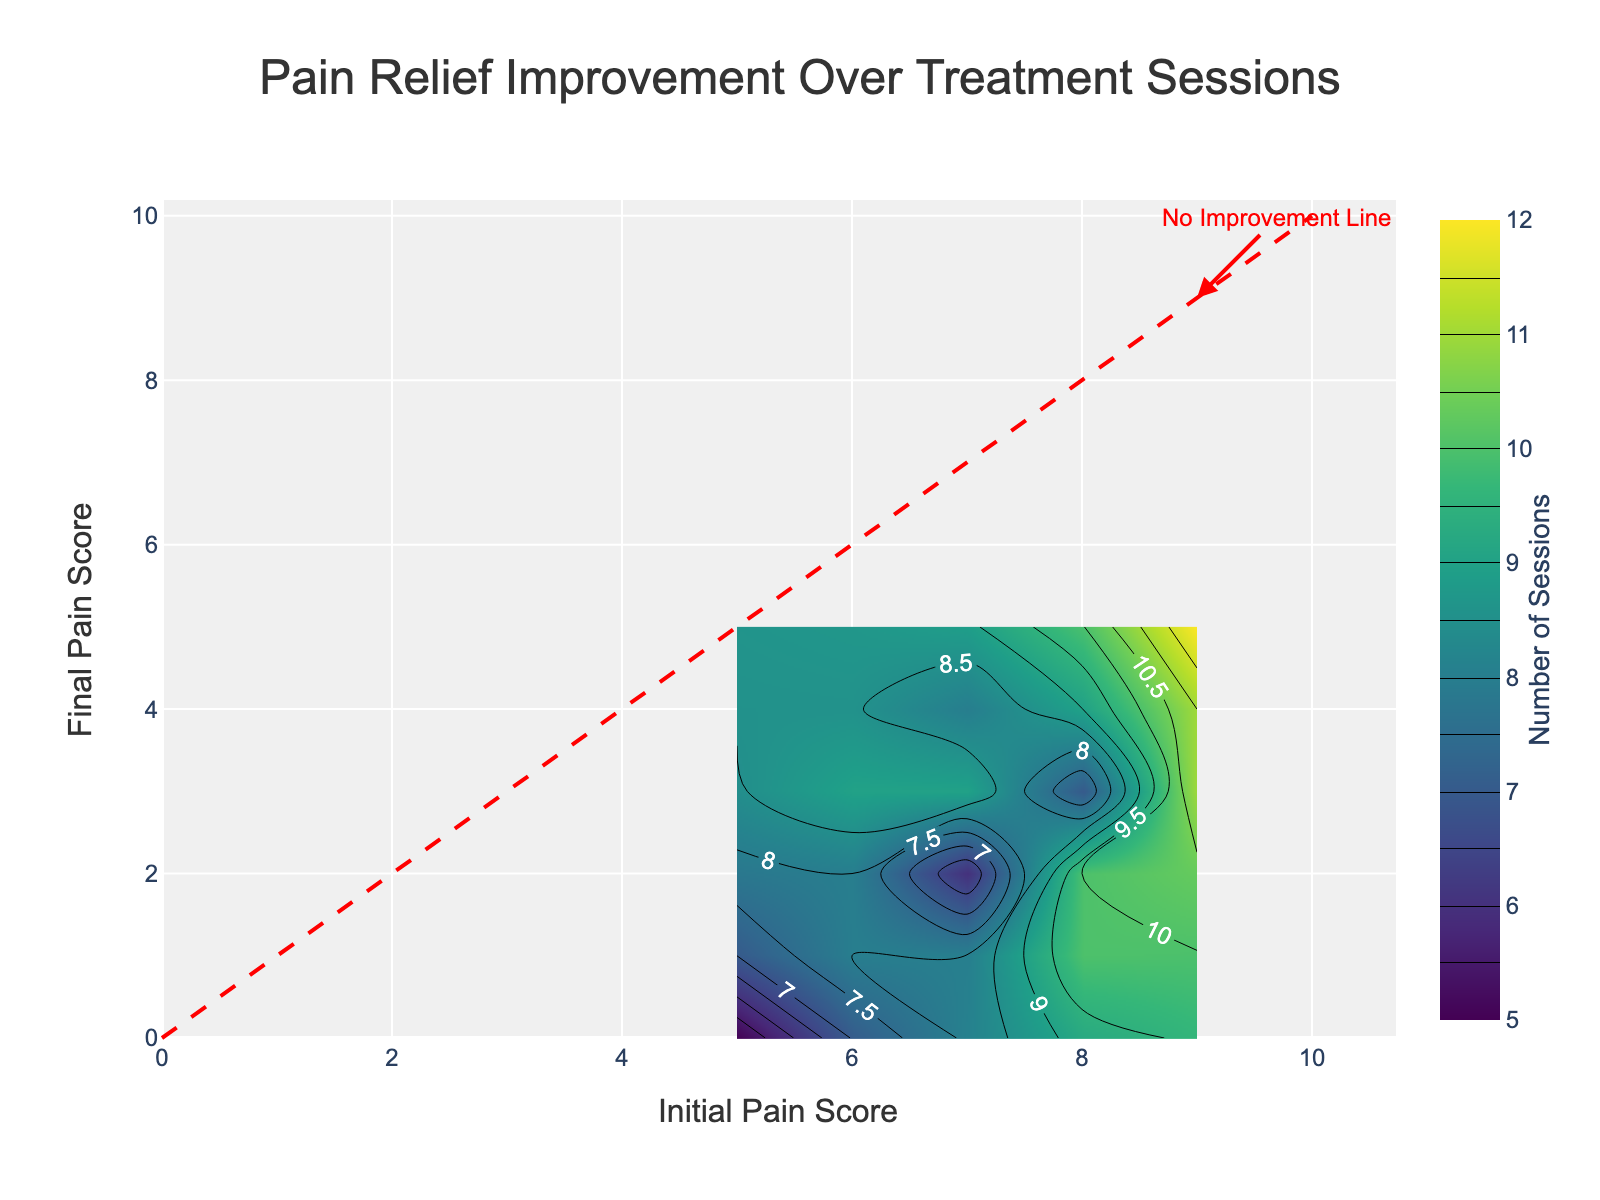What is the title of the figure? The title is placed at the top center of the figure in a larger font and reads "Pain Relief Improvement Over Treatment Sessions."
Answer: Pain Relief Improvement Over Treatment Sessions What does the color bar indicate? The color bar is labeled on the right side of the figure, and its title "Number of Sessions" shows that it represents the number of sessions patients attended.
Answer: Number of Sessions At which initial pain score do we see the maximum number of treatment sessions? Looking at the color bar, the darkest section on the plot (indicating the highest number of sessions) occurs around an initial pain score of 8.
Answer: 8 How does the final pain score change with respect to the initial pain score? Observing the contour lines, the final pain score generally decreases as the initial pain score increases, indicating improvement in pain levels after the treatment.
Answer: Decreases What is the significance of the red dashed line? The red line has an annotation and follows an increasing trend where x equals y, indicating the "No Improvement Line" where the initial pain score equals the final pain score.
Answer: No Improvement Line How many sessions are generally required for a patient with an initial pain score of 9 to achieve a final pain score of 3? By identifying the contour lines and their intersections, where the initial pain score is 9 and the final pain score is 3, it is observed around the color representing approximately 11 sessions.
Answer: 11 Compare the number of sessions required for an initial pain score of 7 to achieve final pain scores of 2, 3, and 4. Observing the contour plot, for a final pain score of 2, it is around 6 sessions; for 3, it is 8 sessions; and for 4, it is approximately 8 sessions as well.
Answer: 6, 8, 8 What can we infer about patients with an initial pain score of 6 in terms of sessions needed for pain reduction to a score of 1? Observing the plot, we can see around the initial score of 6 and final score of 1, the color corresponding to approximately 8 sessions.
Answer: 8 What does a point on the red line represent in terms of patient improvement? A point lying on the red dashed line indicates no improvement in pain relief as it represents equal initial and final pain scores.
Answer: No improvement How do the range and distribution of final pain scores change as the initial pain score increases from 5 to 9? From observing the contour plot, as the initial pain score increases from 5 to 9, the range of final pain scores generally decreases from a larger span to a smaller span (towards lesser scores), indicating higher initial scores likely result in greater pain reduction.
Answer: Range decreases 